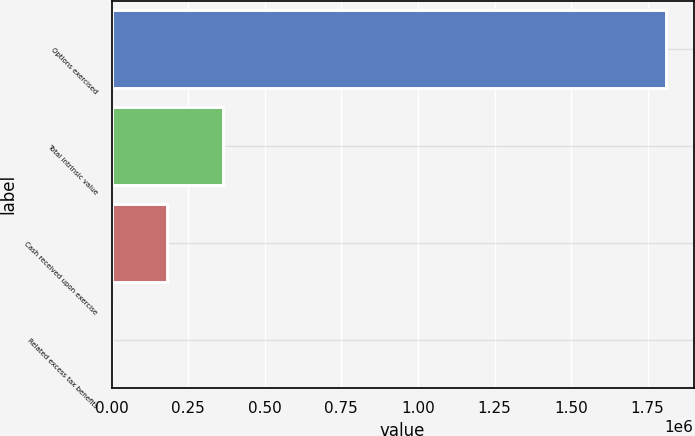<chart> <loc_0><loc_0><loc_500><loc_500><bar_chart><fcel>Options exercised<fcel>Total intrinsic value<fcel>Cash received upon exercise<fcel>Related excess tax benefits<nl><fcel>1.80977e+06<fcel>361976<fcel>181002<fcel>28<nl></chart> 